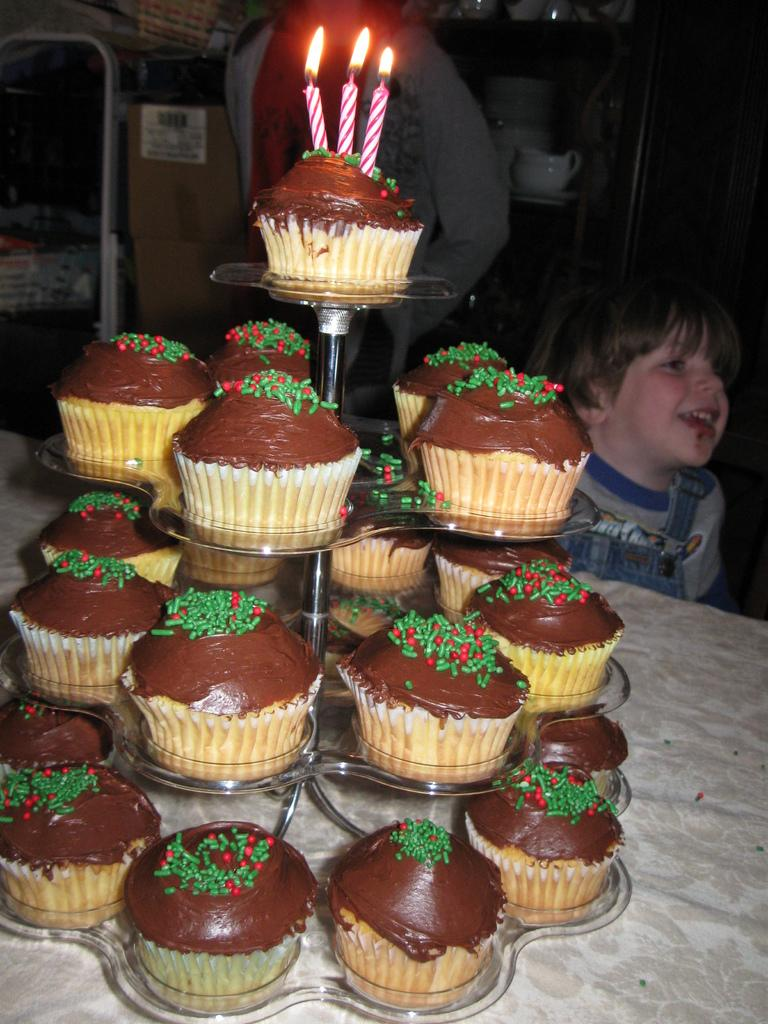What type of food is visible in the image? There are cupcakes in the image. What is placed on top of the cupcakes? Candles are present on the cupcakes. Where are the cupcakes and candles located? They are on a table in the image. Can you describe the boy in the background of the image? The provided facts do not give any information about the boy's appearance or characteristics. What color are the cupcakes? The cupcakes are brown in color. How many turkeys are visible in the image? There are no turkeys present in the image. What unit of measurement is used to determine the size of the cupcakes? The provided facts do not give any information about the size or measurement of the cupcakes. 